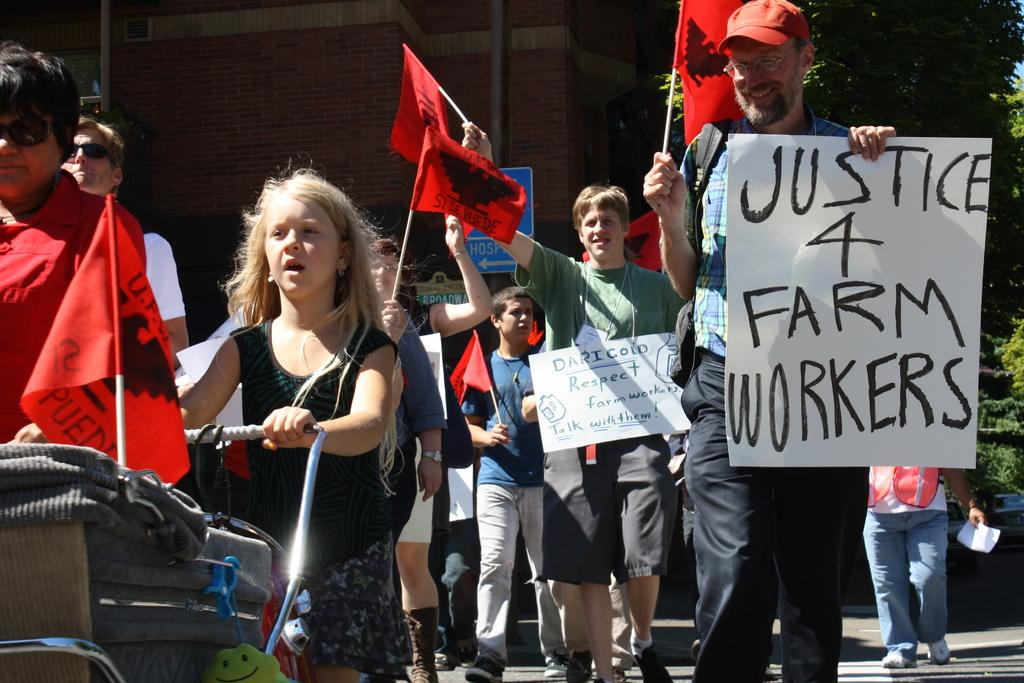What is happening in the image involving the group of people? Some people are holding flags and placards in the image. What can be seen in the hands of some people in the image? Some people are holding flags and placards in the image. What is visible in the background of the image? There are trees and a building in the background of the image. What type of bell can be heard ringing in the image? There is no bell present or audible in the image. What flavor of soda is being consumed by the people in the image? There is no soda present or being consumed in the image. 